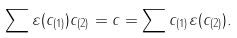<formula> <loc_0><loc_0><loc_500><loc_500>\sum \varepsilon ( c _ { ( 1 ) } ) c _ { ( 2 ) } = c = \sum c _ { ( 1 ) } \varepsilon ( c _ { ( 2 ) } ) .</formula> 